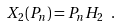Convert formula to latex. <formula><loc_0><loc_0><loc_500><loc_500>X _ { 2 } ( P _ { n } ) = P _ { n } H _ { 2 } \ .</formula> 